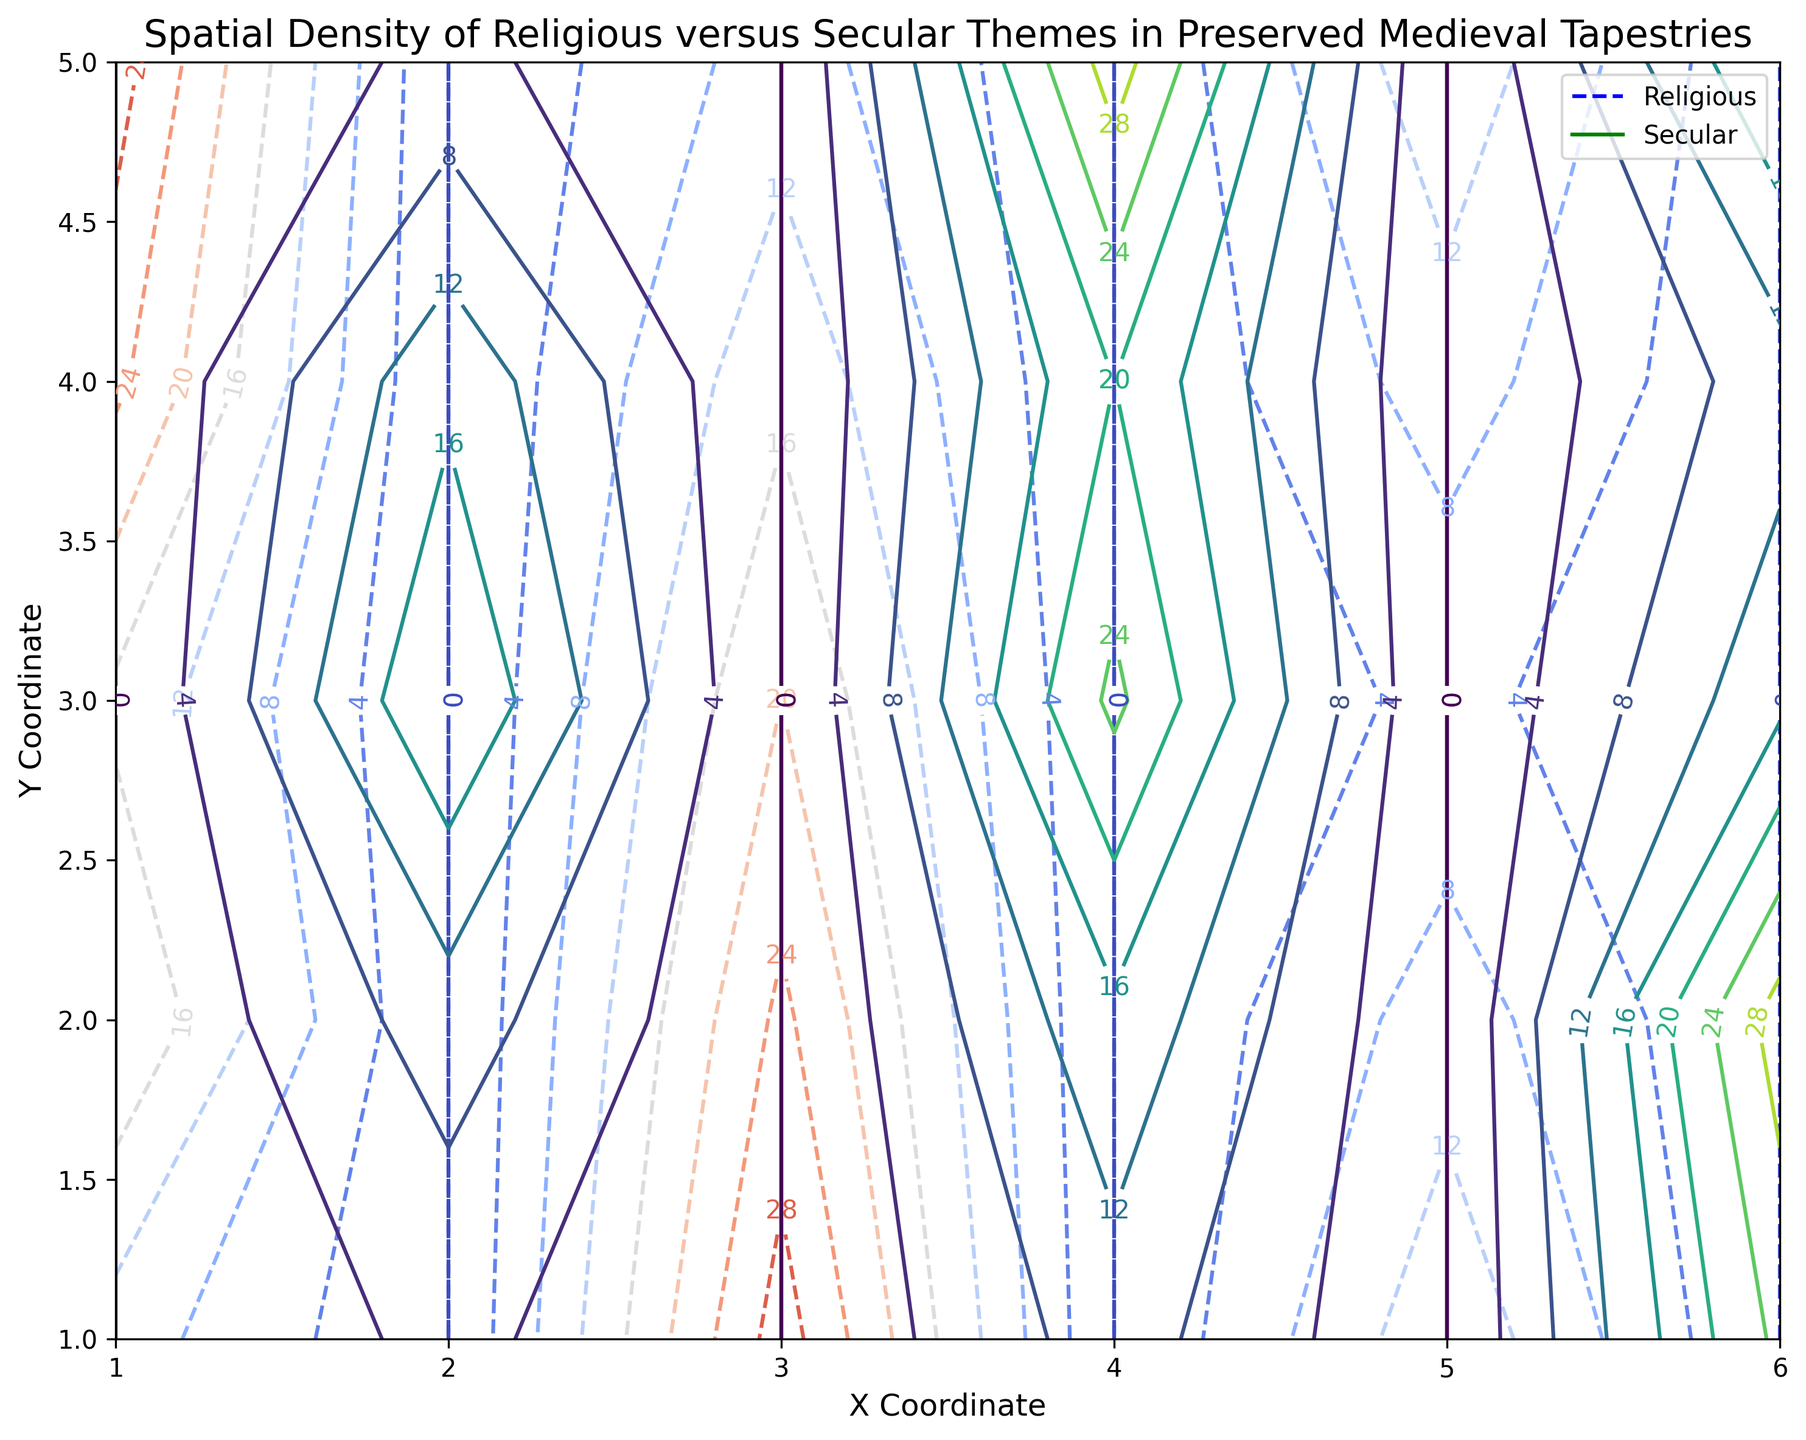What theme shows a higher density at the coordinate (1, 5)? Look at the density values at coordinate (1, 5) for both themes. For religious tapestries, the density is 30, and for secular, it is 5. Compare these values to determine which is higher.
Answer: Religious Which theme exhibits a higher maximum density overall? Compare the highest density values from both themes. The highest density for religious tapestries is 30, found at coordinates (1,5) and (3,1). For secular tapestries, the highest density is also 30, at coordinate (6,2). Since these values are equal, both themes exhibit the same maximum density.
Answer: Both Where is the highest density observed for secular themes? Search for the coordinates with the highest density in secular tapestries. The highest secular density is 30 at coordinate (6, 2).
Answer: Coordinate (6, 2) Which coordinates show overlapping density contours for religious and secular themes? Identify coordinates where contours for both themes overlap. These are coordinates where both themes have densities plotted. The overlapping coordinates based on the provided data are: (2,2), (2,3),(2,4),(4,3),(4,4).
Answer: Coordinates (2,2),(2,3),(2,4),(4,3),(4,4) What is the density difference between religious and secular at coordinate (3, 2)? At coordinate (3, 2), the density for religious is 25, and for secular, it is not specified, meaning it's 0 by default. So the difference is 25 - 0 = 25.
Answer: 25 At which coordinate is the density the same for both themes, given the highest density value? The highest density value for both themes is 30. Check where this value exists for both themes. For religious, it’s at (1, 5) and (3, 1). For secular, it’s at (6, 2) and (4, 5). There is no coordinate where both themes share the density value of 30.
Answer: None How does the overall trend of density for religious themes change along the x-axis from 1 to 6? Observe the density values for religious themes along the x-axis. At x=1, density increases from coordinates 1 to 5 (10 to 30). At x=3, the highest density is at coordinate 1 and decreases from 30 to 10. Along x=5, density shows low variability (15 to 15). Generally, densities show significant fluctuation across different x-coordinate values.
Answer: Fluctuating Is there any coordinate where the secular theme density increases consistently along the y-axis? Check secular theme densities along the y-axis. At x = 4, the density increases consistently from coordinate 1 to 5 (10, 15, 25, 20, 30).
Answer: Yes, at x = 4 